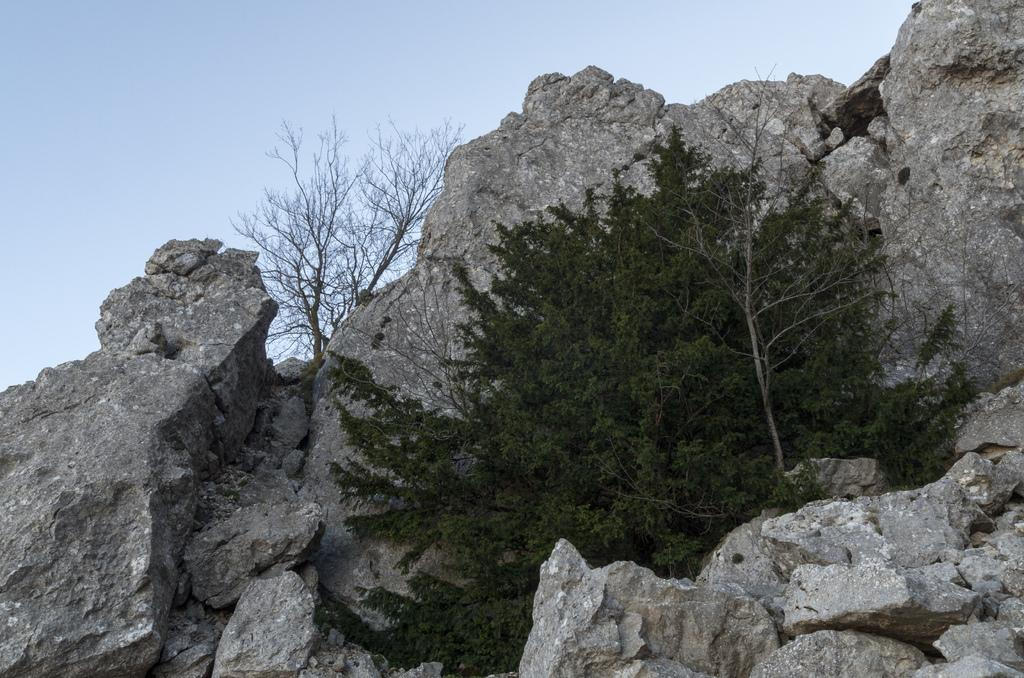What type of natural elements can be seen in the image? There are rocks and trees in the image. What is visible in the background of the image? The sky is visible in the background of the image. Can you see a giraffe eating a cracker with a knife in the image? No, there is no giraffe, cracker, or knife present in the image. 